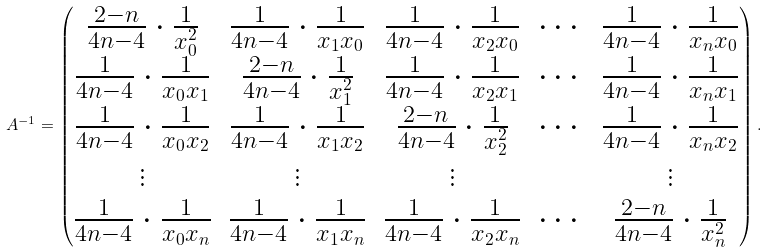<formula> <loc_0><loc_0><loc_500><loc_500>A ^ { - 1 } = \begin{pmatrix} \frac { 2 - n } { 4 n - 4 } \cdot \frac { 1 } { x _ { 0 } ^ { 2 } } & \frac { 1 } { 4 n - 4 } \cdot \frac { 1 } { x _ { 1 } x _ { 0 } } & \frac { 1 } { 4 n - 4 } \cdot \frac { 1 } { x _ { 2 } x _ { 0 } } & \cdots & \frac { 1 } { 4 n - 4 } \cdot \frac { 1 } { x _ { n } x _ { 0 } } \\ \frac { 1 } { 4 n - 4 } \cdot \frac { 1 } { x _ { 0 } x _ { 1 } } & \frac { 2 - n } { 4 n - 4 } \cdot \frac { 1 } { x _ { 1 } ^ { 2 } } & \frac { 1 } { 4 n - 4 } \cdot \frac { 1 } { x _ { 2 } x _ { 1 } } & \cdots & \frac { 1 } { 4 n - 4 } \cdot \frac { 1 } { x _ { n } x _ { 1 } } \\ \frac { 1 } { 4 n - 4 } \cdot \frac { 1 } { x _ { 0 } x _ { 2 } } & \frac { 1 } { 4 n - 4 } \cdot \frac { 1 } { x _ { 1 } x _ { 2 } } & \frac { 2 - n } { 4 n - 4 } \cdot \frac { 1 } { x _ { 2 } ^ { 2 } } & \cdots & \frac { 1 } { 4 n - 4 } \cdot \frac { 1 } { x _ { n } x _ { 2 } } \\ \vdots & \vdots & \vdots & & \vdots \\ \frac { 1 } { 4 n - 4 } \cdot \frac { 1 } { x _ { 0 } x _ { n } } & \frac { 1 } { 4 n - 4 } \cdot \frac { 1 } { x _ { 1 } x _ { n } } & \frac { 1 } { 4 n - 4 } \cdot \frac { 1 } { x _ { 2 } x _ { n } } & \cdots & \frac { 2 - n } { 4 n - 4 } \cdot \frac { 1 } { x _ { n } ^ { 2 } } \\ \end{pmatrix} .</formula> 